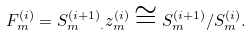<formula> <loc_0><loc_0><loc_500><loc_500>F _ { m } ^ { ( i ) } = { S _ { m } ^ { ( i + 1 ) } } _ { \cdot } z _ { m } ^ { ( i ) } \cong S _ { m } ^ { ( i + 1 ) } / S _ { m } ^ { ( i ) } .</formula> 